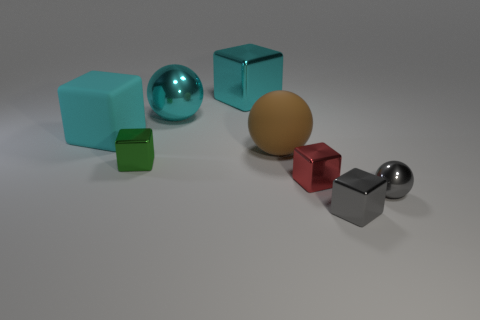Does the small red cube have the same material as the gray thing in front of the tiny gray metallic sphere?
Offer a very short reply. Yes. How many tiny red cylinders are made of the same material as the green block?
Keep it short and to the point. 0. The small green object to the left of the gray block has what shape?
Provide a short and direct response. Cube. Does the big cyan cube right of the green block have the same material as the ball behind the brown matte object?
Give a very brief answer. Yes. Is there a small metal object that has the same shape as the big brown object?
Give a very brief answer. Yes. What number of objects are either objects in front of the small green shiny block or large cyan blocks?
Provide a succinct answer. 5. Are there more rubber objects in front of the tiny green block than big balls that are in front of the cyan sphere?
Provide a short and direct response. No. What number of matte things are either big green blocks or tiny gray balls?
Provide a succinct answer. 0. What is the material of the big ball that is the same color as the large shiny cube?
Provide a succinct answer. Metal. Is the number of shiny cubes that are in front of the red cube less than the number of shiny objects behind the small gray metallic ball?
Ensure brevity in your answer.  Yes. 